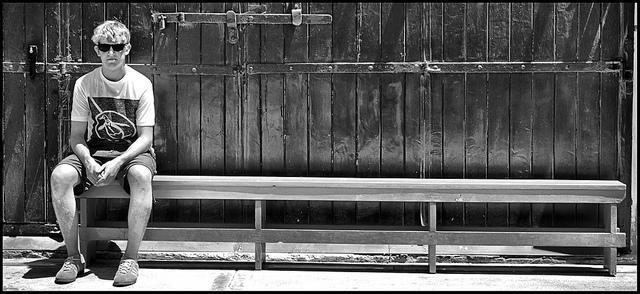How many donuts have chocolate frosting?
Give a very brief answer. 0. 